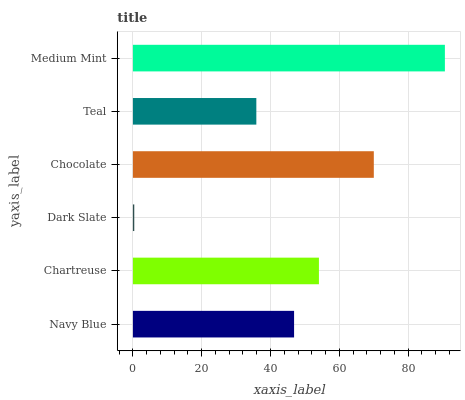Is Dark Slate the minimum?
Answer yes or no. Yes. Is Medium Mint the maximum?
Answer yes or no. Yes. Is Chartreuse the minimum?
Answer yes or no. No. Is Chartreuse the maximum?
Answer yes or no. No. Is Chartreuse greater than Navy Blue?
Answer yes or no. Yes. Is Navy Blue less than Chartreuse?
Answer yes or no. Yes. Is Navy Blue greater than Chartreuse?
Answer yes or no. No. Is Chartreuse less than Navy Blue?
Answer yes or no. No. Is Chartreuse the high median?
Answer yes or no. Yes. Is Navy Blue the low median?
Answer yes or no. Yes. Is Dark Slate the high median?
Answer yes or no. No. Is Chartreuse the low median?
Answer yes or no. No. 